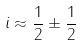Convert formula to latex. <formula><loc_0><loc_0><loc_500><loc_500>i \approx \frac { 1 } { 2 } \pm \frac { 1 } { 2 }</formula> 